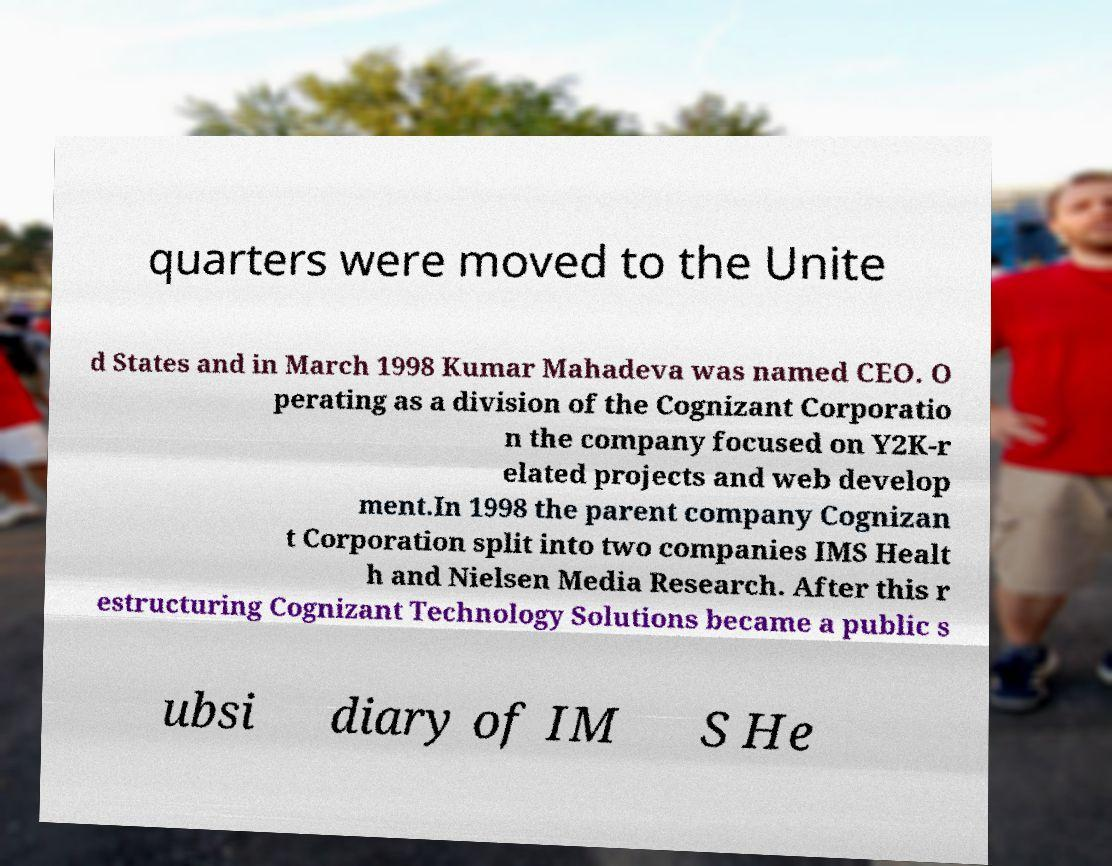What messages or text are displayed in this image? I need them in a readable, typed format. quarters were moved to the Unite d States and in March 1998 Kumar Mahadeva was named CEO. O perating as a division of the Cognizant Corporatio n the company focused on Y2K-r elated projects and web develop ment.In 1998 the parent company Cognizan t Corporation split into two companies IMS Healt h and Nielsen Media Research. After this r estructuring Cognizant Technology Solutions became a public s ubsi diary of IM S He 